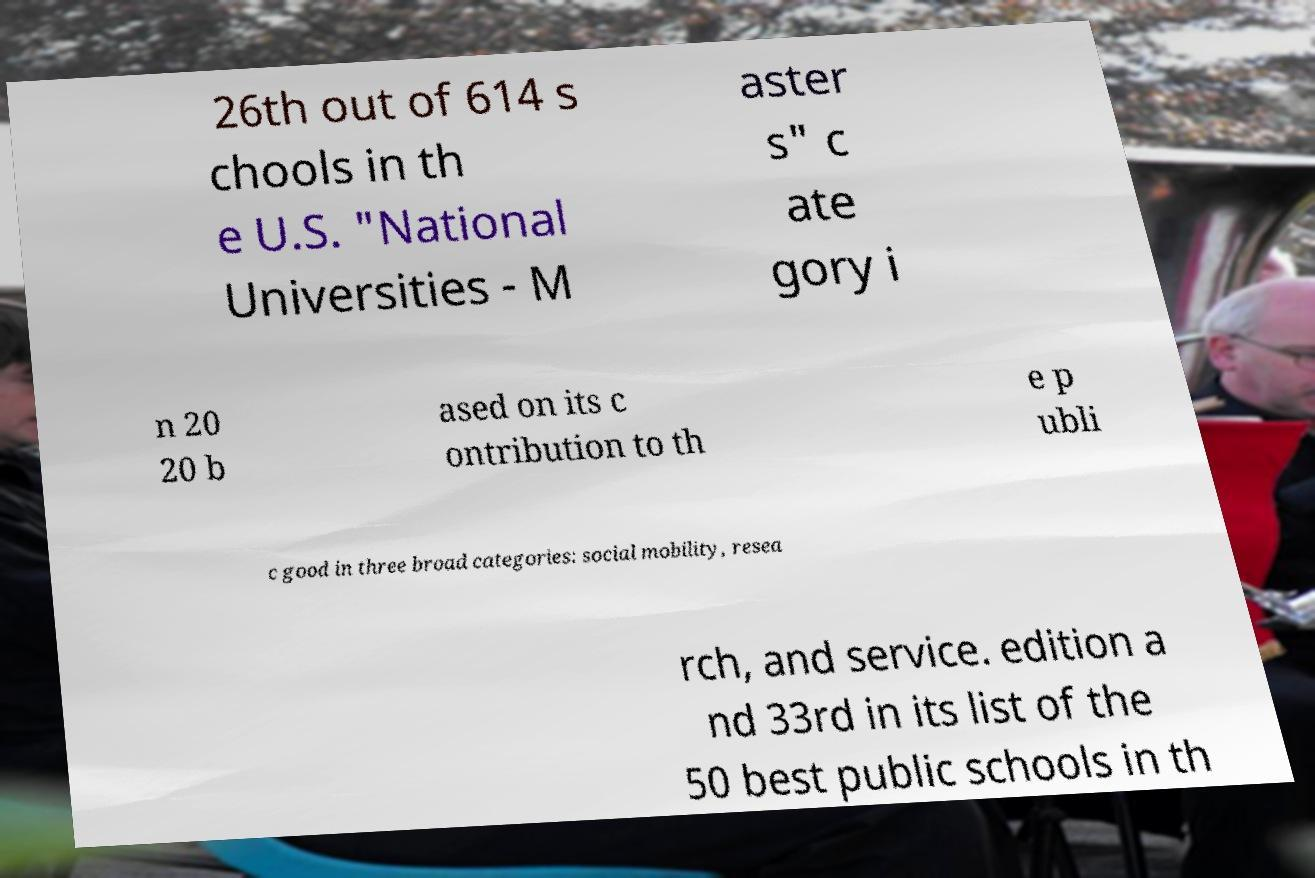Can you accurately transcribe the text from the provided image for me? 26th out of 614 s chools in th e U.S. "National Universities - M aster s" c ate gory i n 20 20 b ased on its c ontribution to th e p ubli c good in three broad categories: social mobility, resea rch, and service. edition a nd 33rd in its list of the 50 best public schools in th 